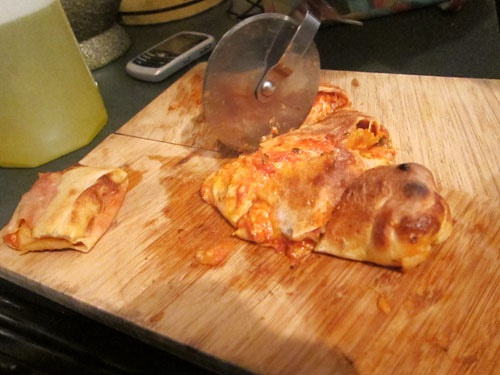Describe the objects in this image and their specific colors. I can see dining table in lightgray, tan, brown, red, and black tones, pizza in lightgray, orange, red, and brown tones, pizza in lightgray, orange, red, and tan tones, and cell phone in lightgray, black, and gray tones in this image. 